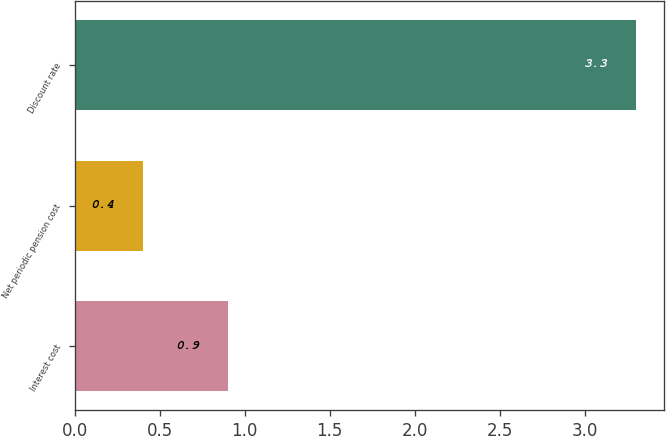<chart> <loc_0><loc_0><loc_500><loc_500><bar_chart><fcel>Interest cost<fcel>Net periodic pension cost<fcel>Discount rate<nl><fcel>0.9<fcel>0.4<fcel>3.3<nl></chart> 